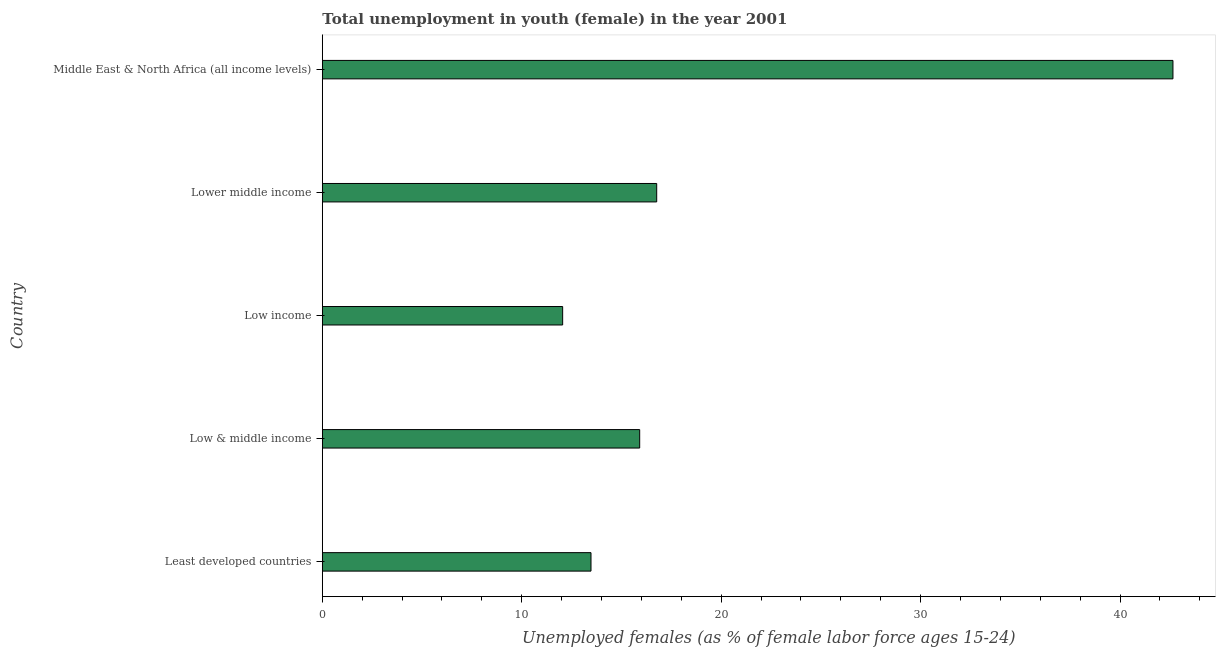Does the graph contain grids?
Provide a succinct answer. No. What is the title of the graph?
Give a very brief answer. Total unemployment in youth (female) in the year 2001. What is the label or title of the X-axis?
Your answer should be very brief. Unemployed females (as % of female labor force ages 15-24). What is the label or title of the Y-axis?
Your response must be concise. Country. What is the unemployed female youth population in Low income?
Ensure brevity in your answer.  12.05. Across all countries, what is the maximum unemployed female youth population?
Keep it short and to the point. 42.65. Across all countries, what is the minimum unemployed female youth population?
Ensure brevity in your answer.  12.05. In which country was the unemployed female youth population maximum?
Make the answer very short. Middle East & North Africa (all income levels). In which country was the unemployed female youth population minimum?
Offer a very short reply. Low income. What is the sum of the unemployed female youth population?
Keep it short and to the point. 100.85. What is the difference between the unemployed female youth population in Low income and Middle East & North Africa (all income levels)?
Give a very brief answer. -30.6. What is the average unemployed female youth population per country?
Provide a succinct answer. 20.17. What is the median unemployed female youth population?
Offer a terse response. 15.91. What is the ratio of the unemployed female youth population in Low & middle income to that in Low income?
Provide a succinct answer. 1.32. What is the difference between the highest and the second highest unemployed female youth population?
Provide a short and direct response. 25.89. Is the sum of the unemployed female youth population in Least developed countries and Lower middle income greater than the maximum unemployed female youth population across all countries?
Your answer should be very brief. No. What is the difference between the highest and the lowest unemployed female youth population?
Your answer should be compact. 30.6. In how many countries, is the unemployed female youth population greater than the average unemployed female youth population taken over all countries?
Keep it short and to the point. 1. What is the difference between two consecutive major ticks on the X-axis?
Provide a short and direct response. 10. Are the values on the major ticks of X-axis written in scientific E-notation?
Ensure brevity in your answer.  No. What is the Unemployed females (as % of female labor force ages 15-24) in Least developed countries?
Keep it short and to the point. 13.47. What is the Unemployed females (as % of female labor force ages 15-24) of Low & middle income?
Offer a very short reply. 15.91. What is the Unemployed females (as % of female labor force ages 15-24) in Low income?
Your response must be concise. 12.05. What is the Unemployed females (as % of female labor force ages 15-24) in Lower middle income?
Your answer should be compact. 16.77. What is the Unemployed females (as % of female labor force ages 15-24) in Middle East & North Africa (all income levels)?
Offer a terse response. 42.65. What is the difference between the Unemployed females (as % of female labor force ages 15-24) in Least developed countries and Low & middle income?
Provide a short and direct response. -2.44. What is the difference between the Unemployed females (as % of female labor force ages 15-24) in Least developed countries and Low income?
Make the answer very short. 1.42. What is the difference between the Unemployed females (as % of female labor force ages 15-24) in Least developed countries and Lower middle income?
Keep it short and to the point. -3.29. What is the difference between the Unemployed females (as % of female labor force ages 15-24) in Least developed countries and Middle East & North Africa (all income levels)?
Offer a very short reply. -29.18. What is the difference between the Unemployed females (as % of female labor force ages 15-24) in Low & middle income and Low income?
Offer a very short reply. 3.86. What is the difference between the Unemployed females (as % of female labor force ages 15-24) in Low & middle income and Lower middle income?
Ensure brevity in your answer.  -0.85. What is the difference between the Unemployed females (as % of female labor force ages 15-24) in Low & middle income and Middle East & North Africa (all income levels)?
Offer a very short reply. -26.74. What is the difference between the Unemployed females (as % of female labor force ages 15-24) in Low income and Lower middle income?
Provide a short and direct response. -4.72. What is the difference between the Unemployed females (as % of female labor force ages 15-24) in Low income and Middle East & North Africa (all income levels)?
Your answer should be very brief. -30.6. What is the difference between the Unemployed females (as % of female labor force ages 15-24) in Lower middle income and Middle East & North Africa (all income levels)?
Your response must be concise. -25.89. What is the ratio of the Unemployed females (as % of female labor force ages 15-24) in Least developed countries to that in Low & middle income?
Provide a succinct answer. 0.85. What is the ratio of the Unemployed females (as % of female labor force ages 15-24) in Least developed countries to that in Low income?
Offer a terse response. 1.12. What is the ratio of the Unemployed females (as % of female labor force ages 15-24) in Least developed countries to that in Lower middle income?
Keep it short and to the point. 0.8. What is the ratio of the Unemployed females (as % of female labor force ages 15-24) in Least developed countries to that in Middle East & North Africa (all income levels)?
Offer a terse response. 0.32. What is the ratio of the Unemployed females (as % of female labor force ages 15-24) in Low & middle income to that in Low income?
Provide a short and direct response. 1.32. What is the ratio of the Unemployed females (as % of female labor force ages 15-24) in Low & middle income to that in Lower middle income?
Keep it short and to the point. 0.95. What is the ratio of the Unemployed females (as % of female labor force ages 15-24) in Low & middle income to that in Middle East & North Africa (all income levels)?
Provide a short and direct response. 0.37. What is the ratio of the Unemployed females (as % of female labor force ages 15-24) in Low income to that in Lower middle income?
Make the answer very short. 0.72. What is the ratio of the Unemployed females (as % of female labor force ages 15-24) in Low income to that in Middle East & North Africa (all income levels)?
Give a very brief answer. 0.28. What is the ratio of the Unemployed females (as % of female labor force ages 15-24) in Lower middle income to that in Middle East & North Africa (all income levels)?
Provide a short and direct response. 0.39. 